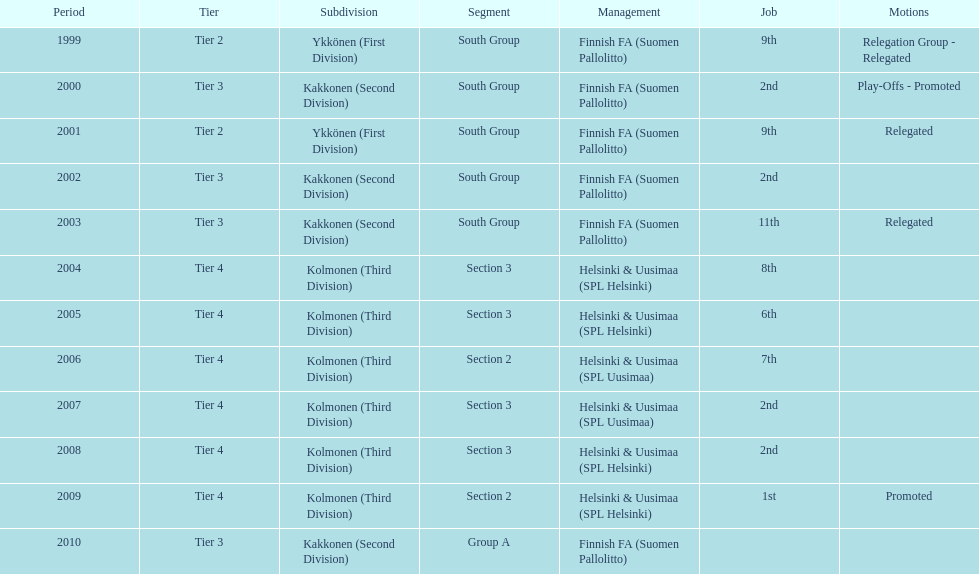What division were they in the most, section 3 or 2? 3. 